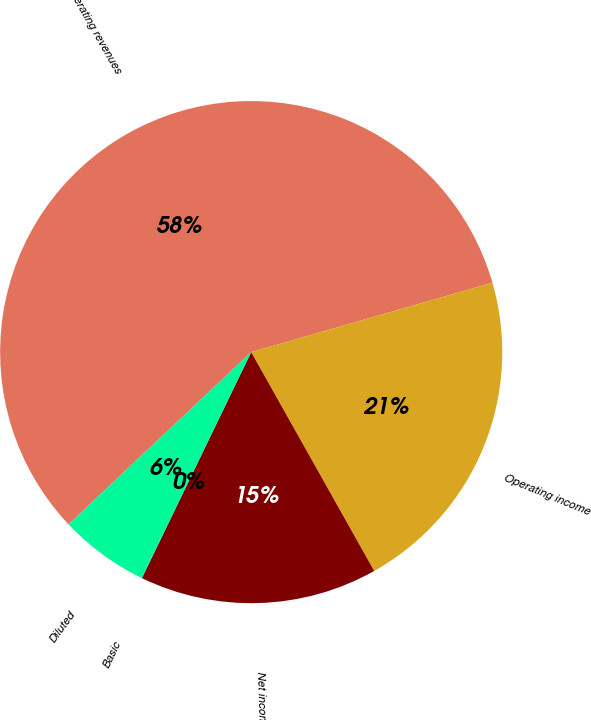Convert chart. <chart><loc_0><loc_0><loc_500><loc_500><pie_chart><fcel>Operating revenues<fcel>Operating income<fcel>Net income<fcel>Basic<fcel>Diluted<nl><fcel>57.58%<fcel>21.31%<fcel>15.32%<fcel>0.02%<fcel>5.78%<nl></chart> 